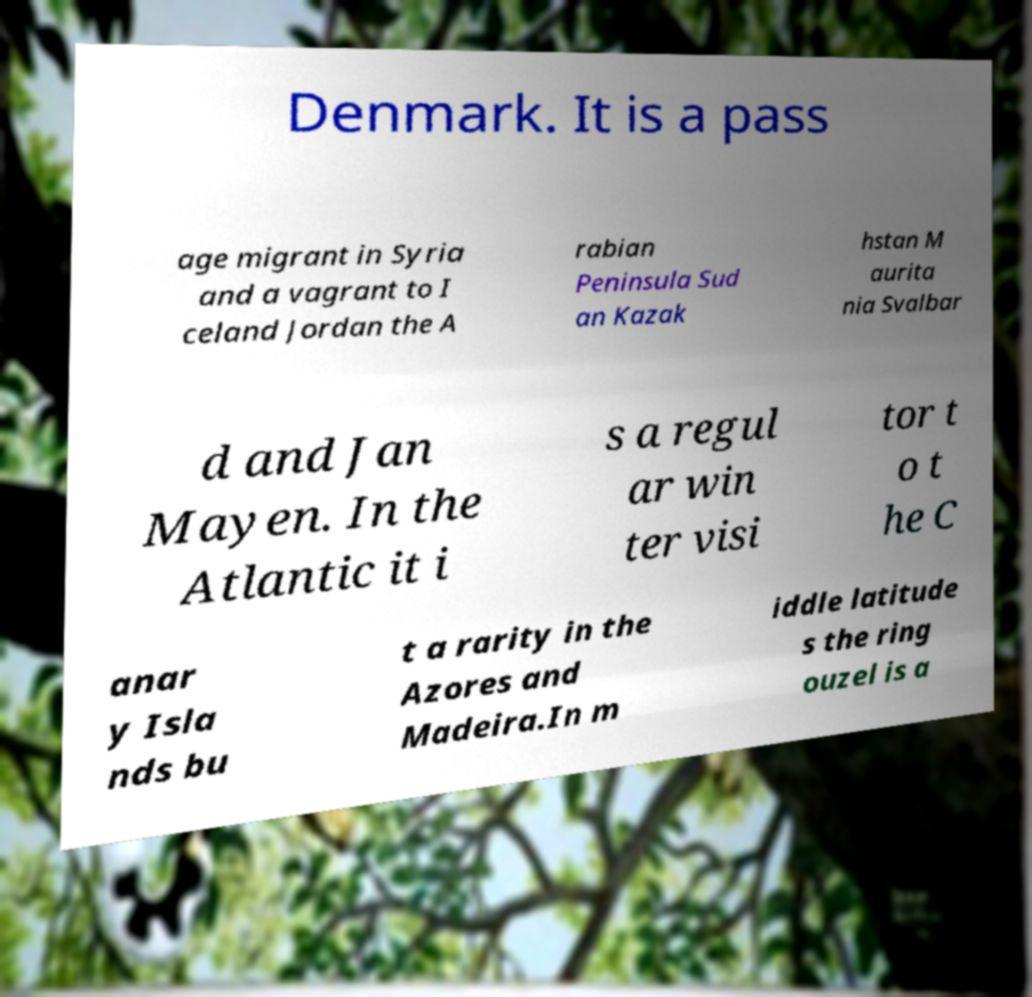Please read and relay the text visible in this image. What does it say? Denmark. It is a pass age migrant in Syria and a vagrant to I celand Jordan the A rabian Peninsula Sud an Kazak hstan M aurita nia Svalbar d and Jan Mayen. In the Atlantic it i s a regul ar win ter visi tor t o t he C anar y Isla nds bu t a rarity in the Azores and Madeira.In m iddle latitude s the ring ouzel is a 